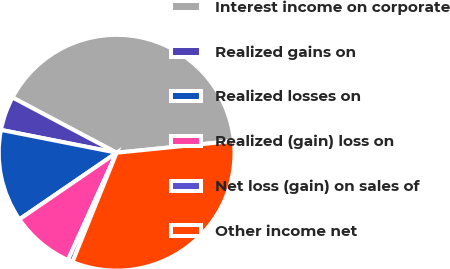Convert chart. <chart><loc_0><loc_0><loc_500><loc_500><pie_chart><fcel>Interest income on corporate<fcel>Realized gains on<fcel>Realized losses on<fcel>Realized (gain) loss on<fcel>Net loss (gain) on sales of<fcel>Other income net<nl><fcel>40.64%<fcel>4.66%<fcel>12.66%<fcel>8.66%<fcel>0.67%<fcel>32.71%<nl></chart> 